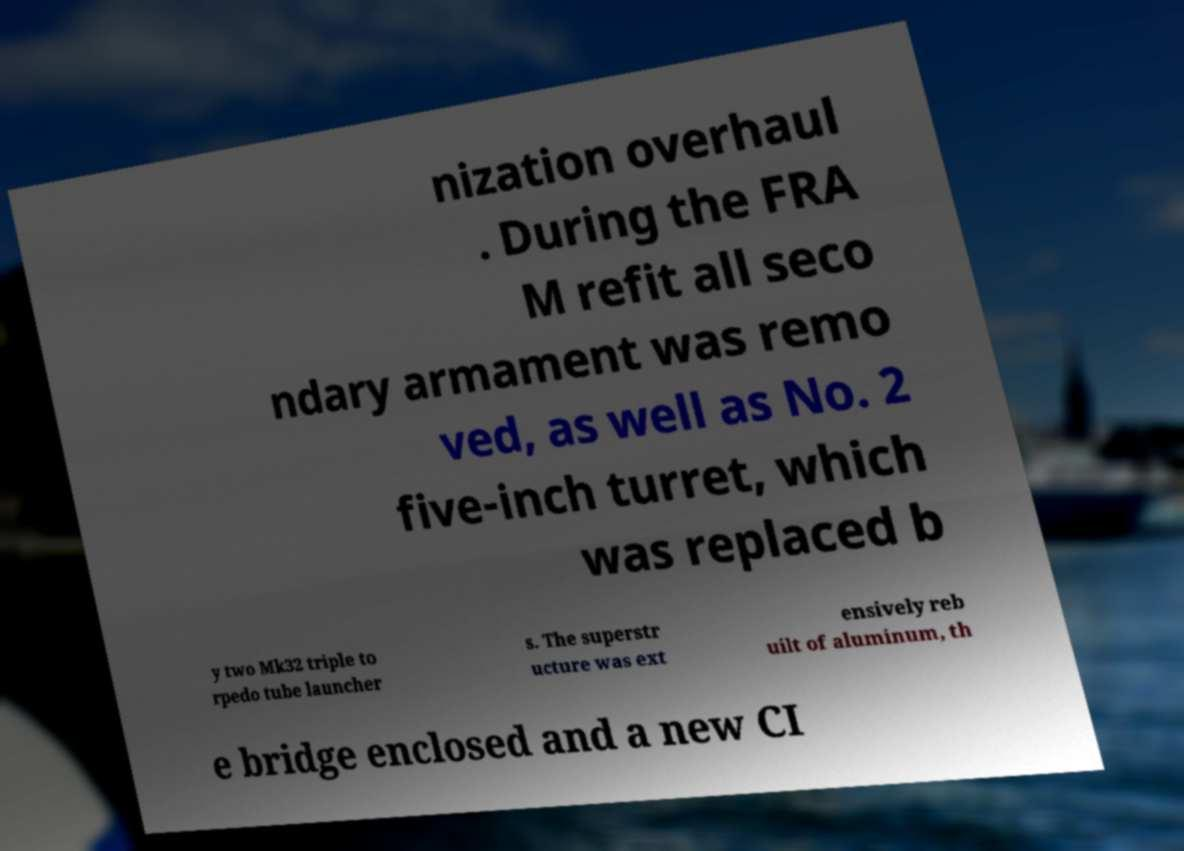Could you assist in decoding the text presented in this image and type it out clearly? nization overhaul . During the FRA M refit all seco ndary armament was remo ved, as well as No. 2 five-inch turret, which was replaced b y two Mk32 triple to rpedo tube launcher s. The superstr ucture was ext ensively reb uilt of aluminum, th e bridge enclosed and a new CI 